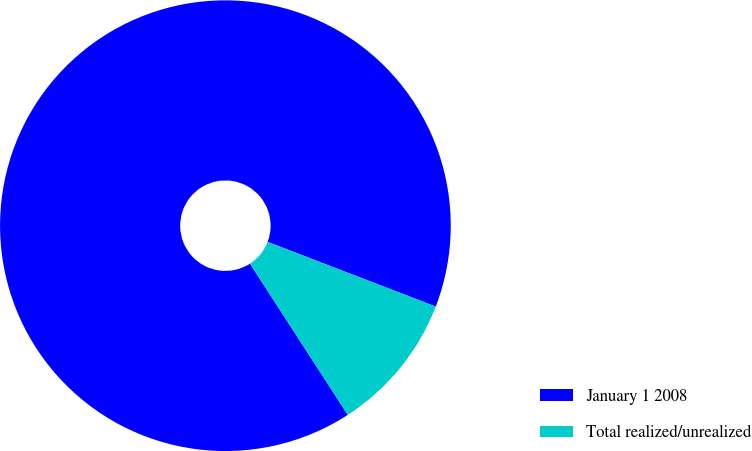Convert chart to OTSL. <chart><loc_0><loc_0><loc_500><loc_500><pie_chart><fcel>January 1 2008<fcel>Total realized/unrealized<nl><fcel>89.98%<fcel>10.02%<nl></chart> 